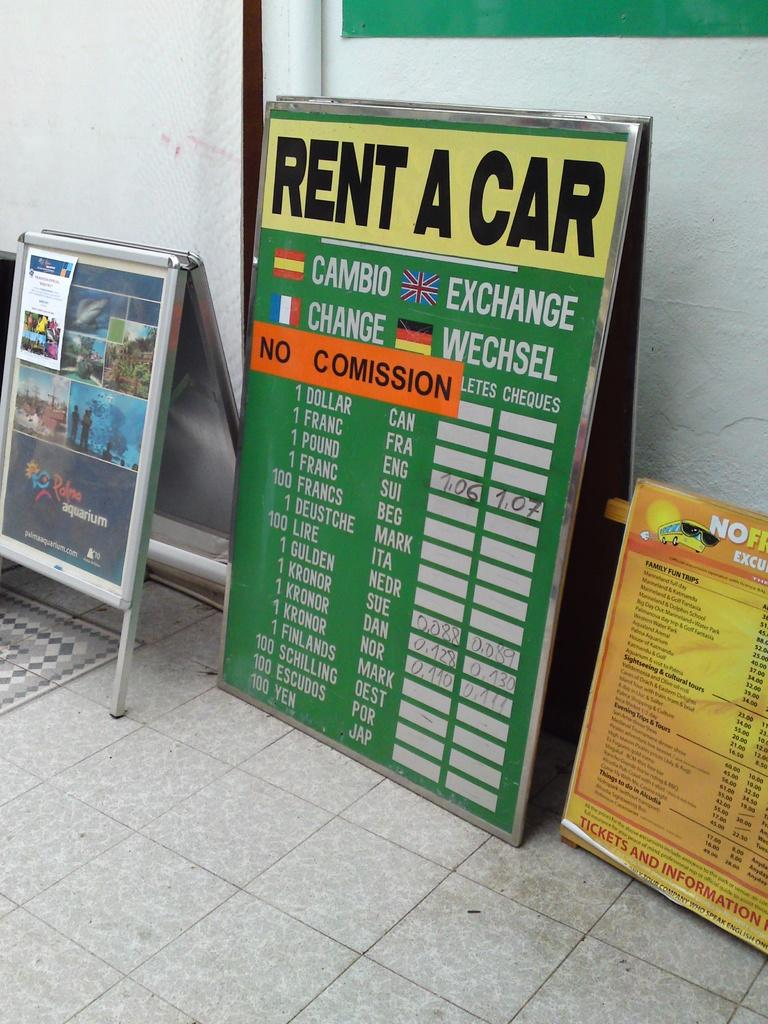<image>
Relay a brief, clear account of the picture shown. Several signs normally seen on streets and one is about renting a car. 